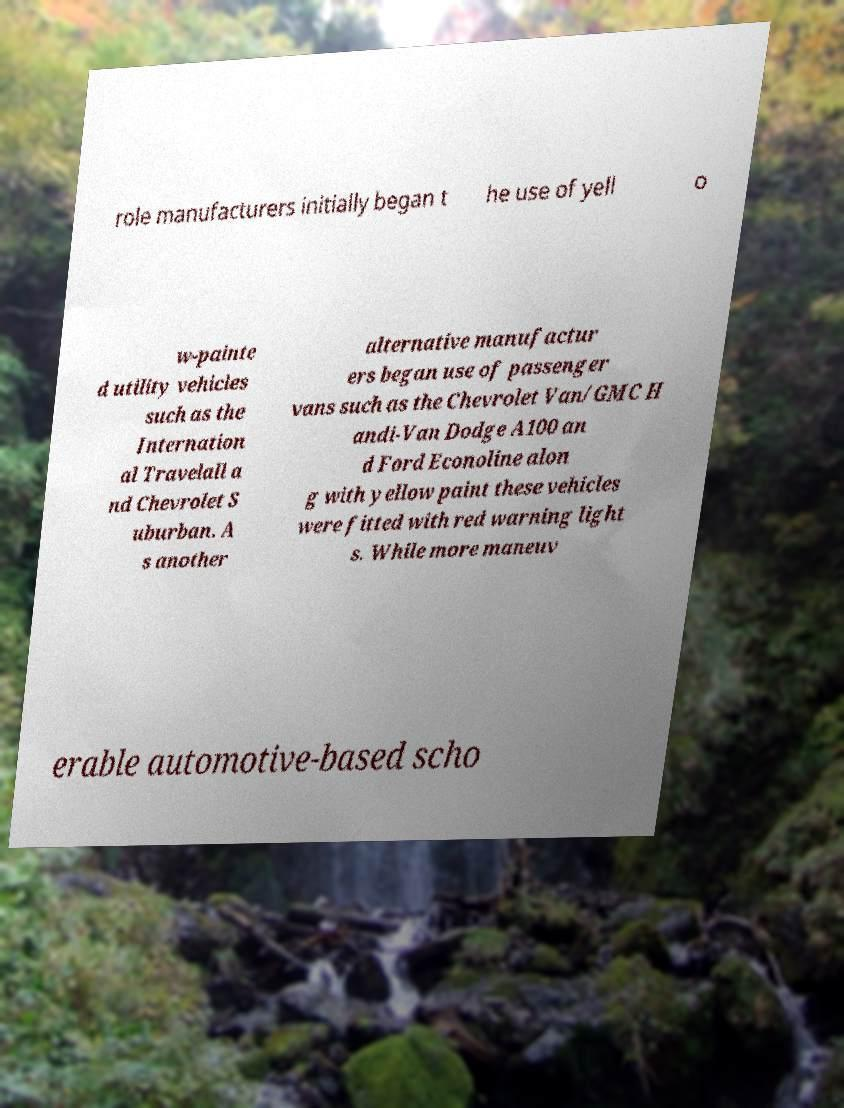There's text embedded in this image that I need extracted. Can you transcribe it verbatim? role manufacturers initially began t he use of yell o w-painte d utility vehicles such as the Internation al Travelall a nd Chevrolet S uburban. A s another alternative manufactur ers began use of passenger vans such as the Chevrolet Van/GMC H andi-Van Dodge A100 an d Ford Econoline alon g with yellow paint these vehicles were fitted with red warning light s. While more maneuv erable automotive-based scho 